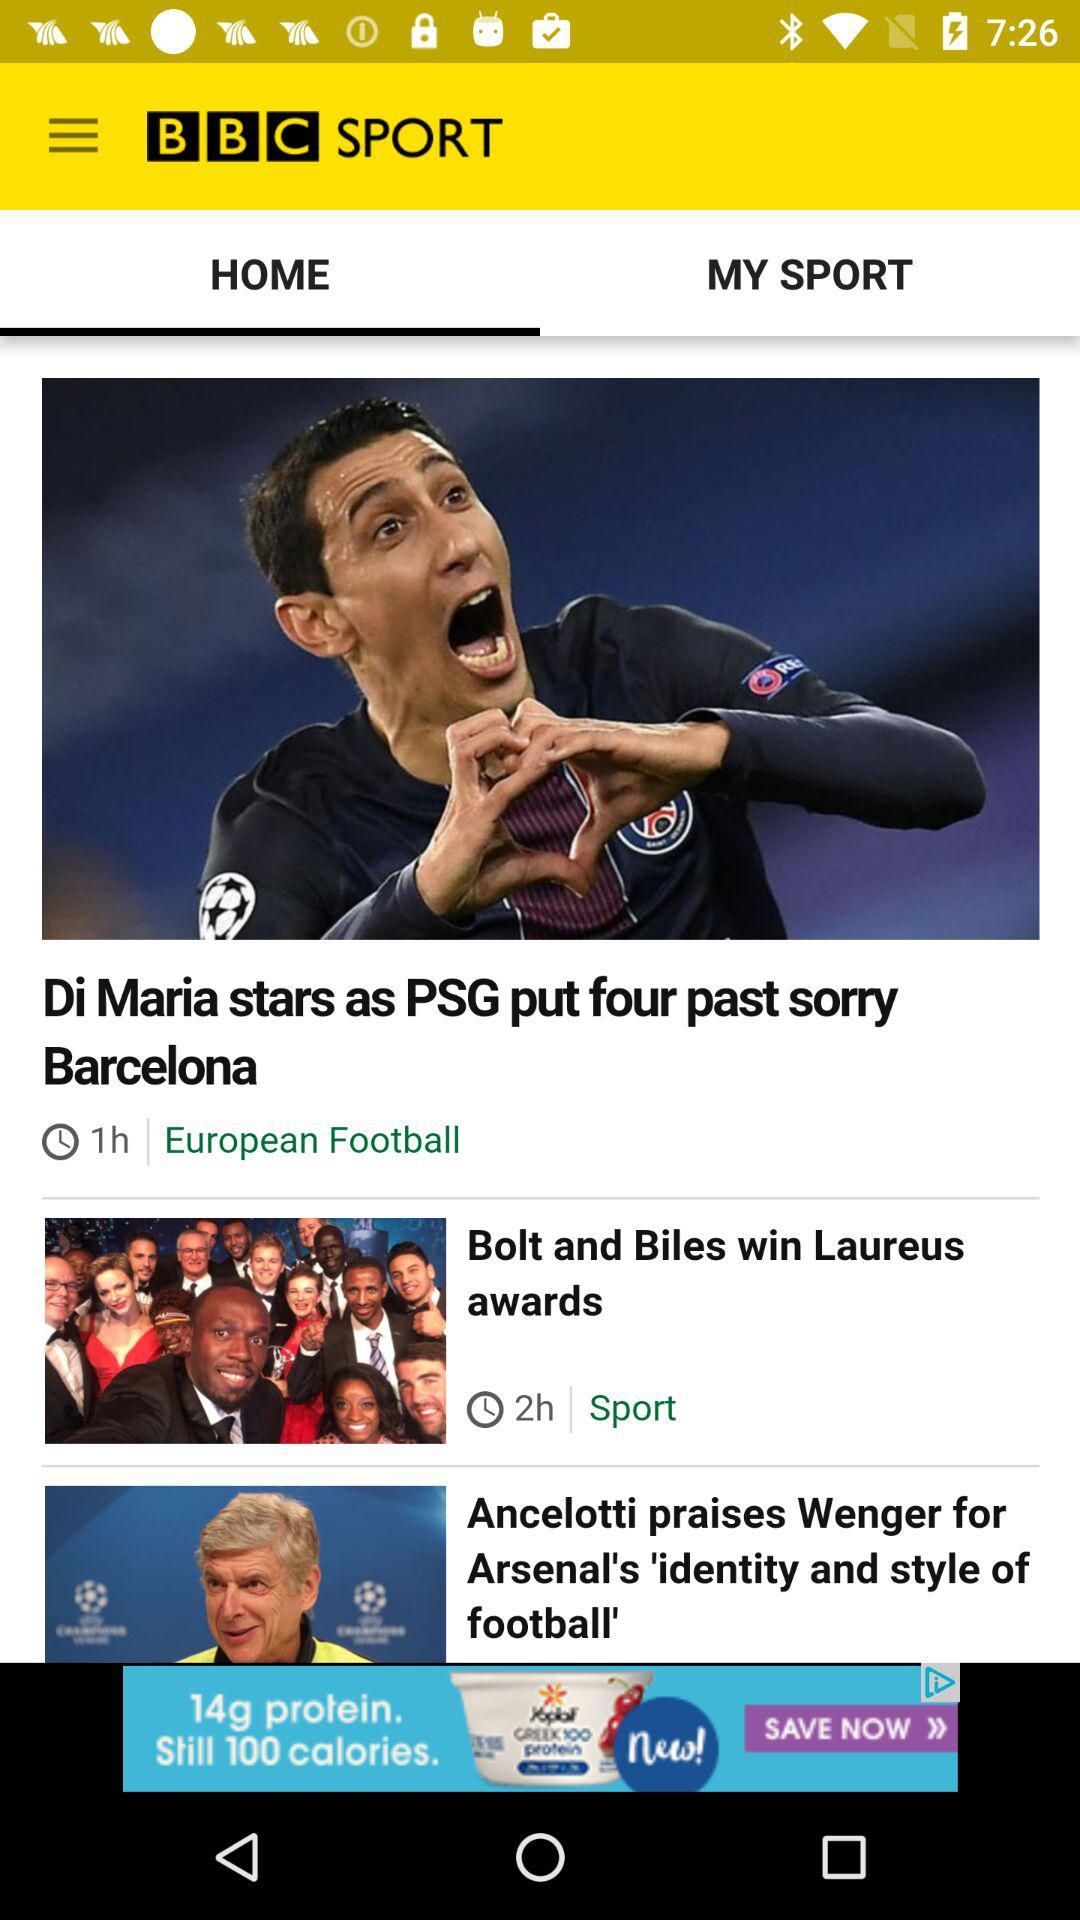What is the title of the news story that was published two hours ago? The title is "Bolt and Biles win Laureus awards". 